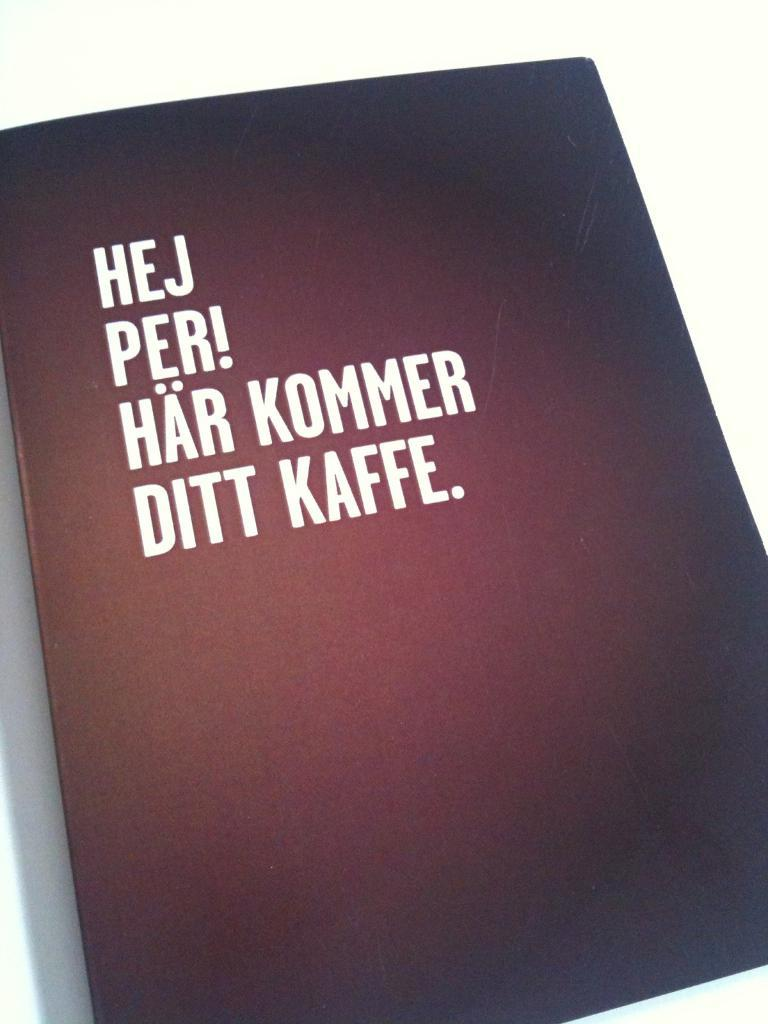<image>
Describe the image concisely. The front of a text that says HEJ  PER! for the title. 